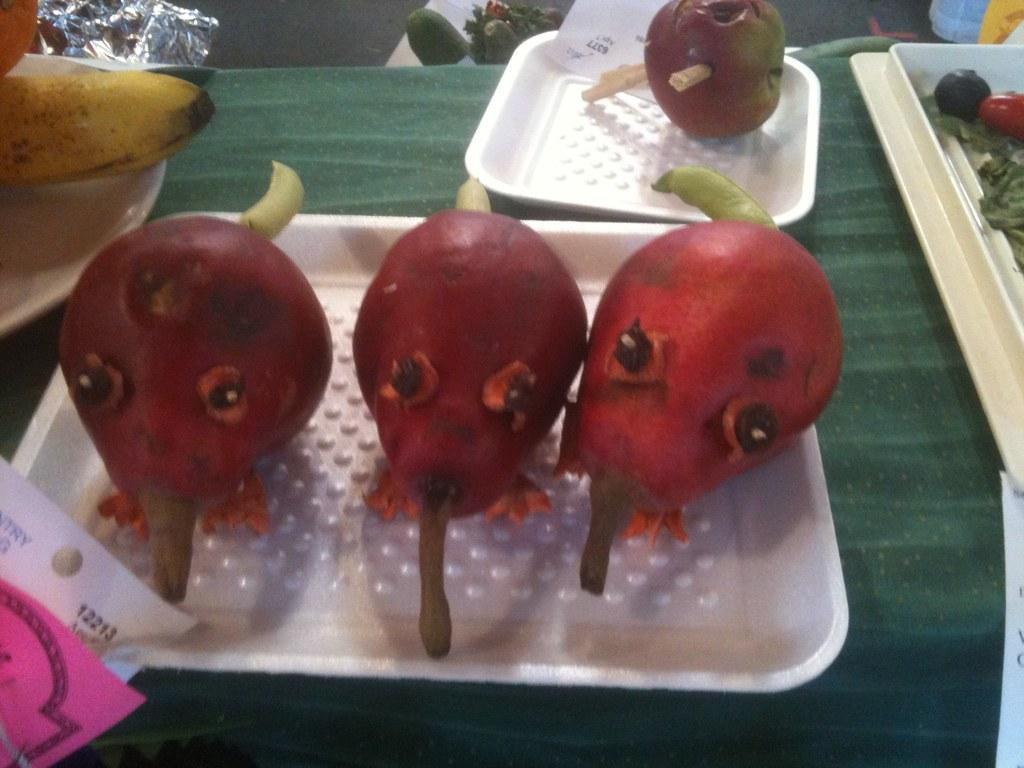Can you describe this image briefly? There is a table. On the table there is a green cloth. On that there are trays. On the trays there are different fruits. On the left corner there are papers. 